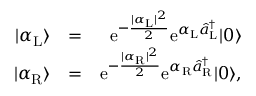<formula> <loc_0><loc_0><loc_500><loc_500>\begin{array} { r l r } { | \alpha _ { L } \rangle } & { = } & { e ^ { - \frac { | \alpha _ { L } | ^ { 2 } } { 2 } } e ^ { \alpha _ { L } \hat { a } _ { L } ^ { \dagger } } | 0 \rangle } \\ { | \alpha _ { R } \rangle } & { = } & { e ^ { - \frac { | \alpha _ { R } | ^ { 2 } } { 2 } } e ^ { \alpha _ { R } \hat { a } _ { R } ^ { \dagger } } | 0 \rangle , } \end{array}</formula> 